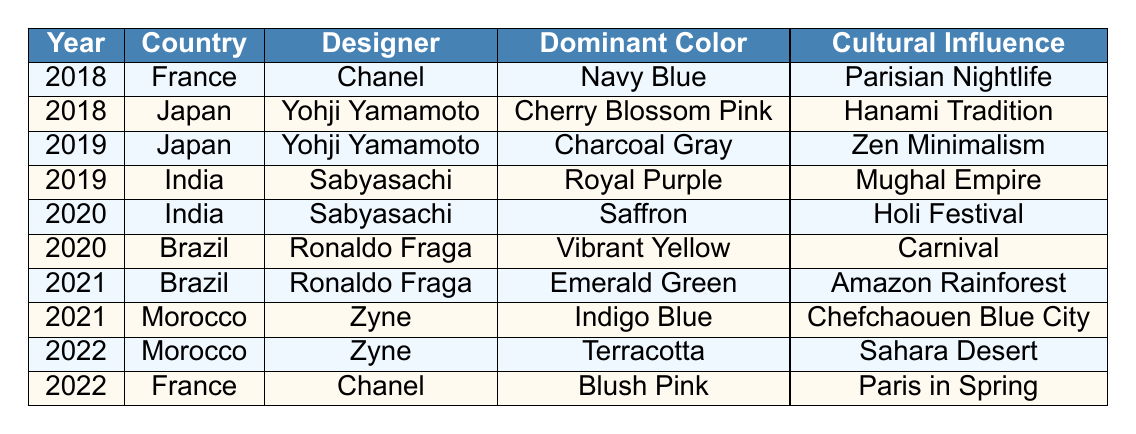What was the dominant color in India for the year 2020? Looking at the table for the year 2020, we see that in India, the designer Sabyasachi had the dominant color Saffron.
Answer: Saffron Which designer from Morocco had a color influenced by the Sahara Desert, and what was that color? In the table, for the year 2022, the designer Zyne from Morocco had the dominant color Terracotta influenced by the Sahara Desert.
Answer: Zyne; Terracotta Did any of the designers use a shade of blue in their collections? By reviewing the table, we find that the dominant color Navy Blue was used by Chanel in 2018 and Indigo Blue was used by Zyne in 2021. Therefore, the answer is yes.
Answer: Yes What color was the dominant choice for France in 2018 and 2022, and how do they compare? In 2018, the dominant color for France was Navy Blue, and in 2022, it was Blush Pink. Both colors were influenced by Parisian aesthetics, but they represent different seasons and moods: nightlife versus spring.
Answer: Navy Blue and Blush Pink Which country had a designer associated with both Charcoal Gray and Vibrant Yellow? By inspecting the table, we notice that Charcoal Gray is related to Japan (Yohji Yamamoto in 2019), while Vibrant Yellow comes from Brazil (Ronaldo Fraga in 2020). Therefore, there’s no country with both colors.
Answer: No country What is the cultural influence behind the dominant color Saffron in India for the year 2020? In the table for 2020, the dominant color Saffron was associated with the cultural influence of the Holi Festival in India.
Answer: Holi Festival Which designer had the most distinct cultural influences in their color choices among all years listed? Examining the table, Sabyasachi (India) showcased cultural influences such as Holi Festival in 2020 and Mughal Empire in 2019, indicating a rich cultural expression through color.
Answer: Sabyasachi Was there any color associated with a rainforest, and if so, which country and designer does it relate to? In the table, the color Emerald Green is associated with the Amazon Rainforest, designed by Ronaldo Fraga for Brazil in 2021.
Answer: Emerald Green; Ronaldo Fraga; Brazil Count the number of different dominant colors used by designers across all five years. The distinct dominant colors listed are Navy Blue, Cherry Blossom Pink, Charcoal Gray, Royal Purple, Saffron, Vibrant Yellow, Emerald Green, Indigo Blue, Terracotta, and Blush Pink, totaling ten different colors.
Answer: 10 What is the relationship between cultural influences and the dominant color choices made by the designers? Each dominant color reflects its cultural influence: Navy Blue relates to nightlife, Saffron to the Holi Festival, and Terracotta to the Sahara Desert, showcasing how regional and cultural aspects shape fashion.
Answer: Cultural relevance shaped colors Which country had designers showcasing two different shades of pink, and what were those shades? Referring to the table, Japan had Cherry Blossom Pink in 2018 and France had Blush Pink in 2022, making two shades of pink across different countries.
Answer: Two pinks; Japan and France 